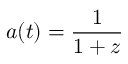Convert formula to latex. <formula><loc_0><loc_0><loc_500><loc_500>\, a ( t ) = { \frac { 1 } { 1 + z } }</formula> 